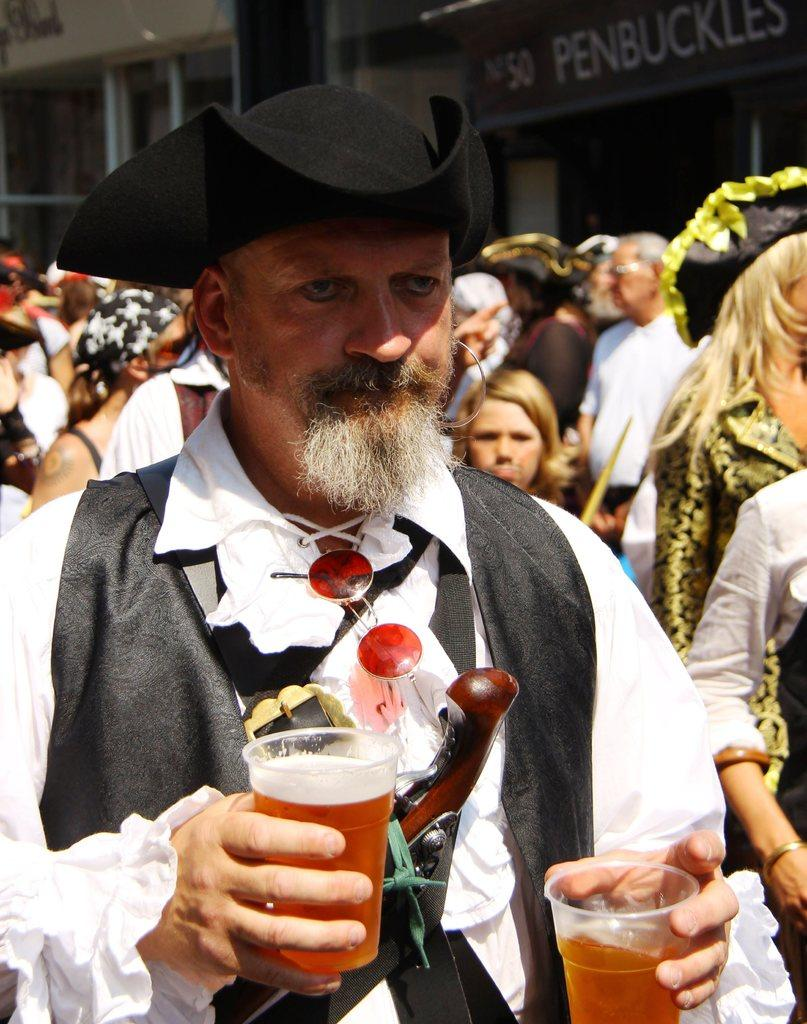Who is the main subject in the image? There is a man in the image. What is the man holding in the image? The man is holding two glasses of red juice. Can you describe the people behind the man? There are many people behind the man. What can be seen in the background of the image? There is a shop named "PENBUCKLES" in the background of the image. What type of insurance does the shop "PENBUCKLES" offer in the image? There is no information about insurance offered by the shop "PENBUCKLES" in the image. 